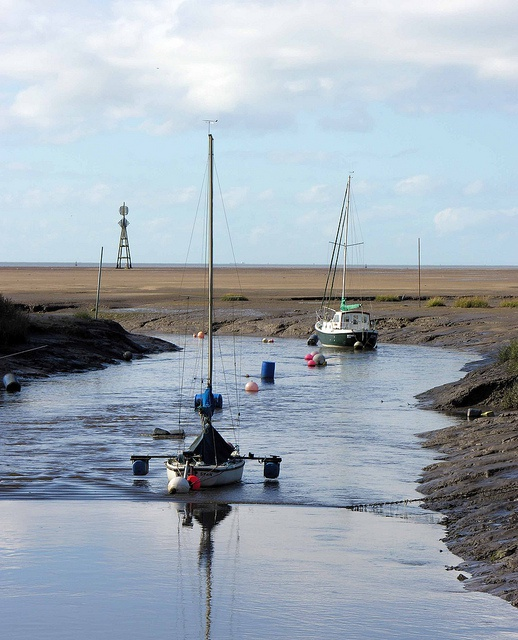Describe the objects in this image and their specific colors. I can see boat in white, black, lightblue, gray, and darkgray tones and boat in white, gray, lightgray, lightblue, and black tones in this image. 